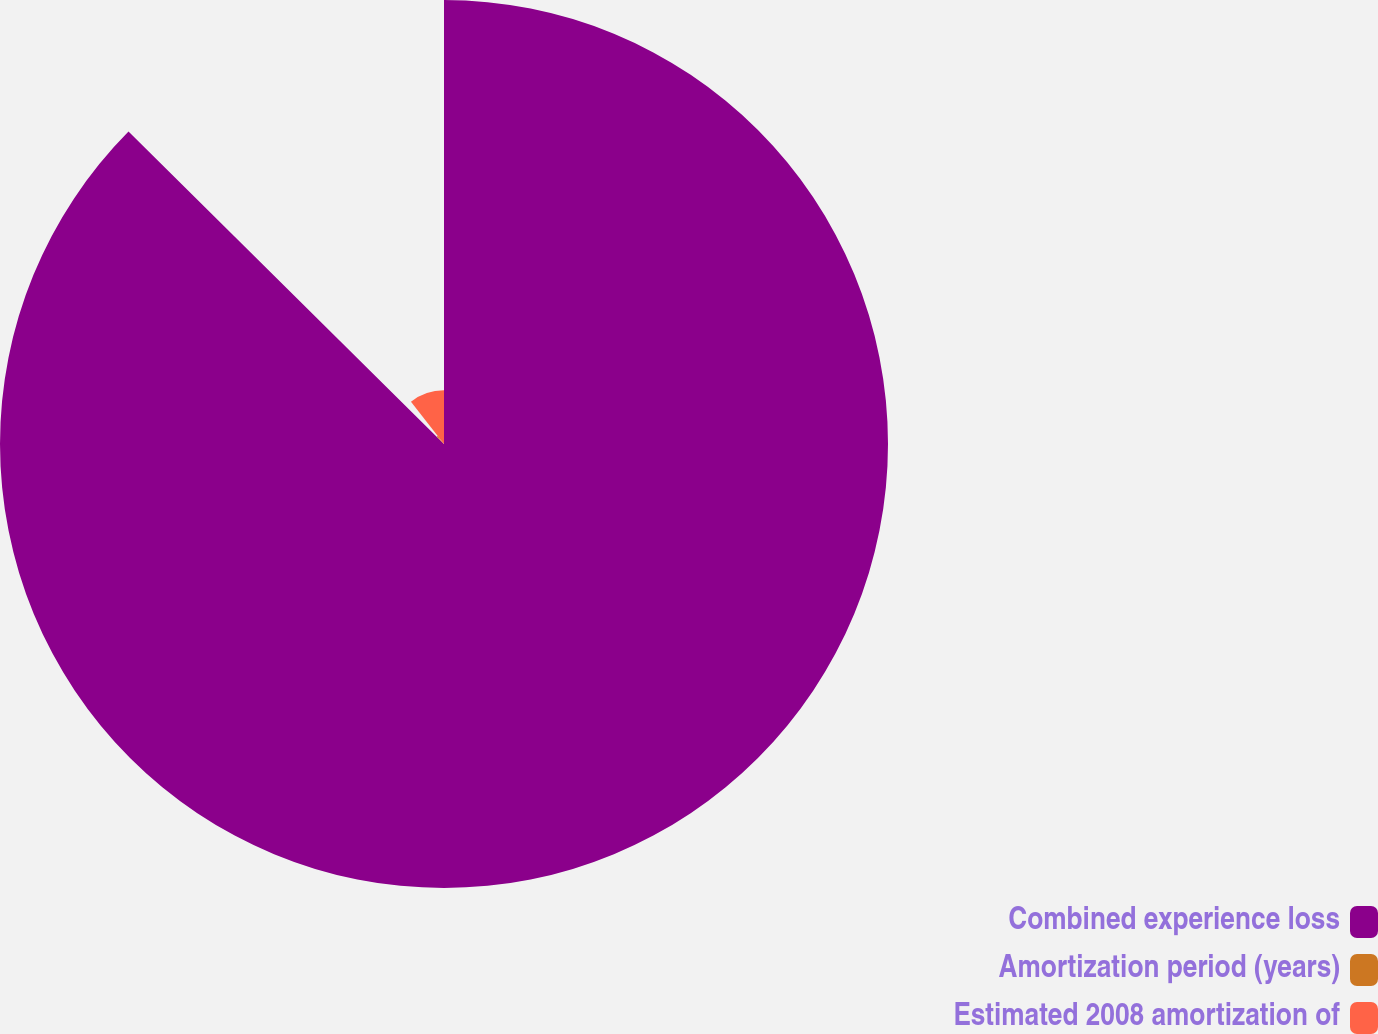Convert chart to OTSL. <chart><loc_0><loc_0><loc_500><loc_500><pie_chart><fcel>Combined experience loss<fcel>Amortization period (years)<fcel>Estimated 2008 amortization of<nl><fcel>87.43%<fcel>2.02%<fcel>10.56%<nl></chart> 